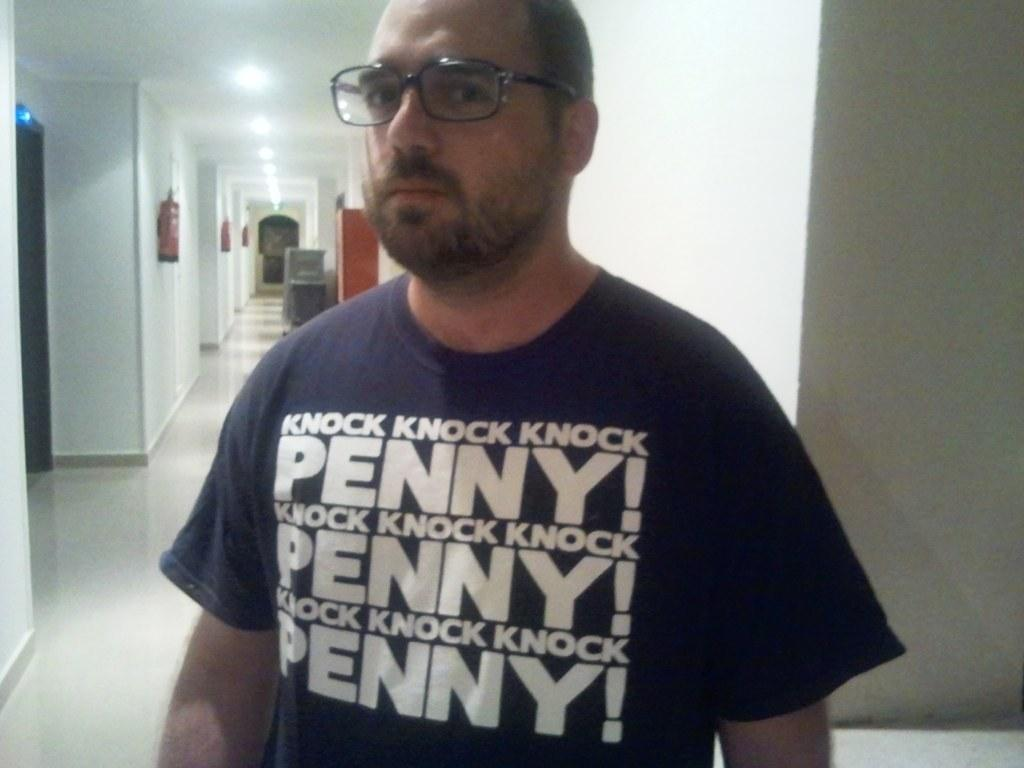What is the main subject of the image? There is a person standing in the image. Where is the person standing? The person is standing on the floor. What can be seen in the background of the image? There is a wall, fire extinguishers, a door, and ceiling lights visible in the background. How many tickets does the person have in their hand in the image? There is no indication in the image that the person is holding any tickets. 